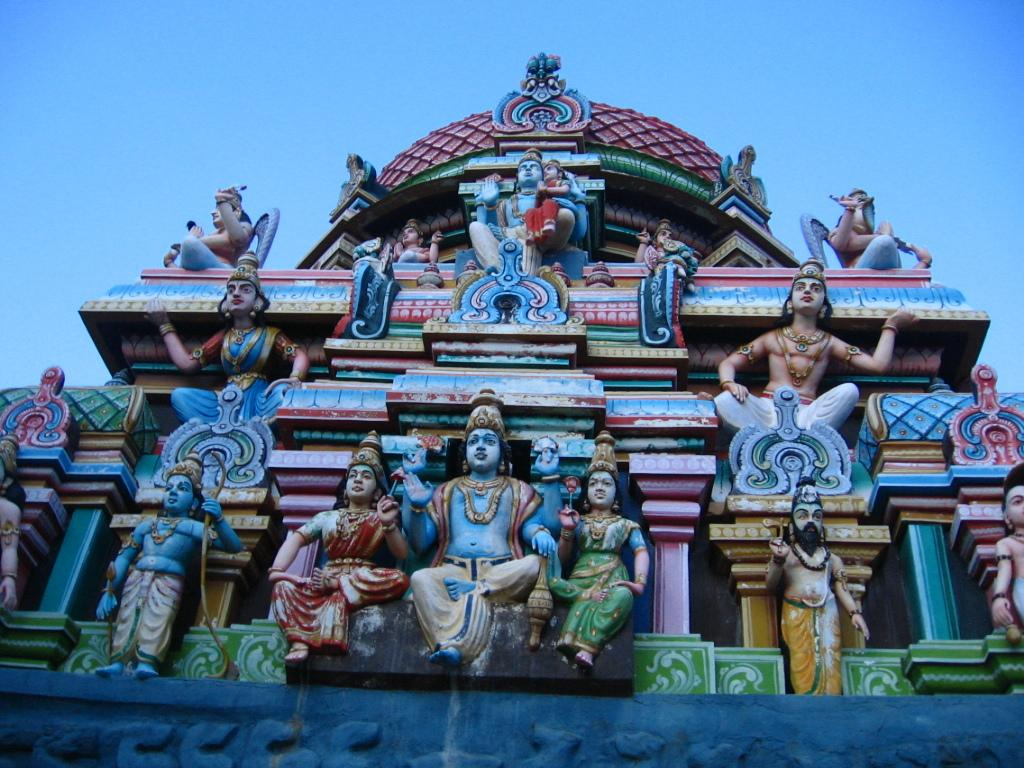What type of building is in the image? There is a temple in the image. What can be found inside the temple? The temple contains idols. What is visible in the background of the image? The sky is visible in the image. What type of rose can be seen growing near the church in the image? There is no church or rose present in the image; it features a temple with idols and a visible sky. How much salt is sprinkled on the idols in the temple? There is no mention of salt in the image, and it is not customary to sprinkle salt on idols in a temple. 